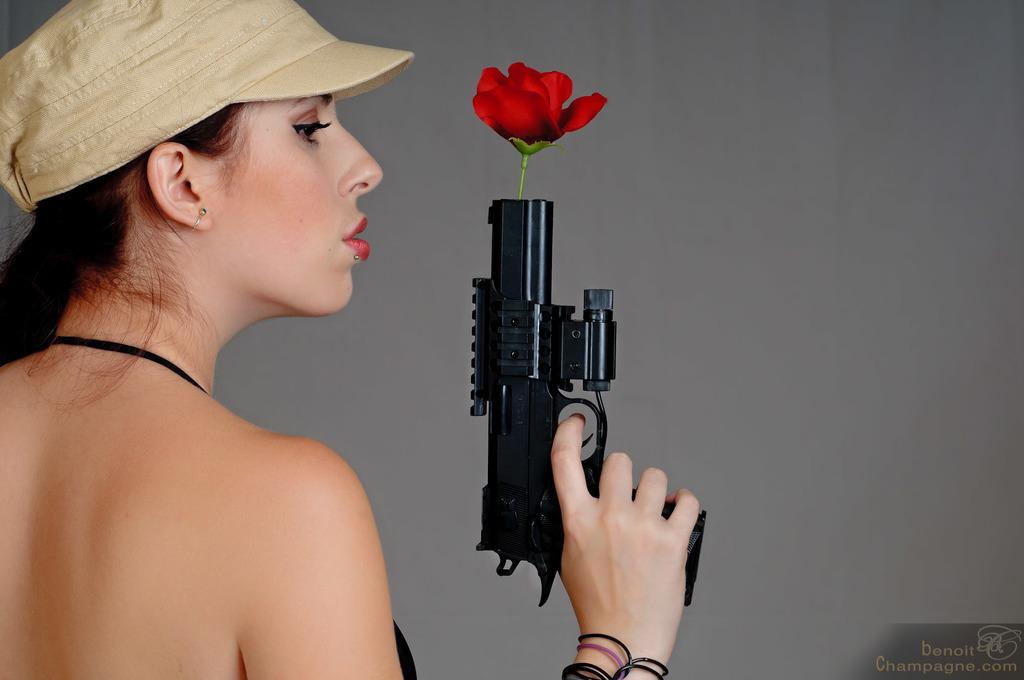Who is present in the image? There is a woman in the image. What is the woman holding in the image? The woman is holding a gun. What is unique about the gun in the image? There is a rose inside the hole of the gun. What type of headwear is the woman wearing? The woman is wearing a hat. What color is the background of the image? The background of the woman is in grey color. What type of fang can be seen in the image? There is no fang present in the image. What type of growth is visible on the woman's face in the image? There is no growth visible on the woman's face in the image. 